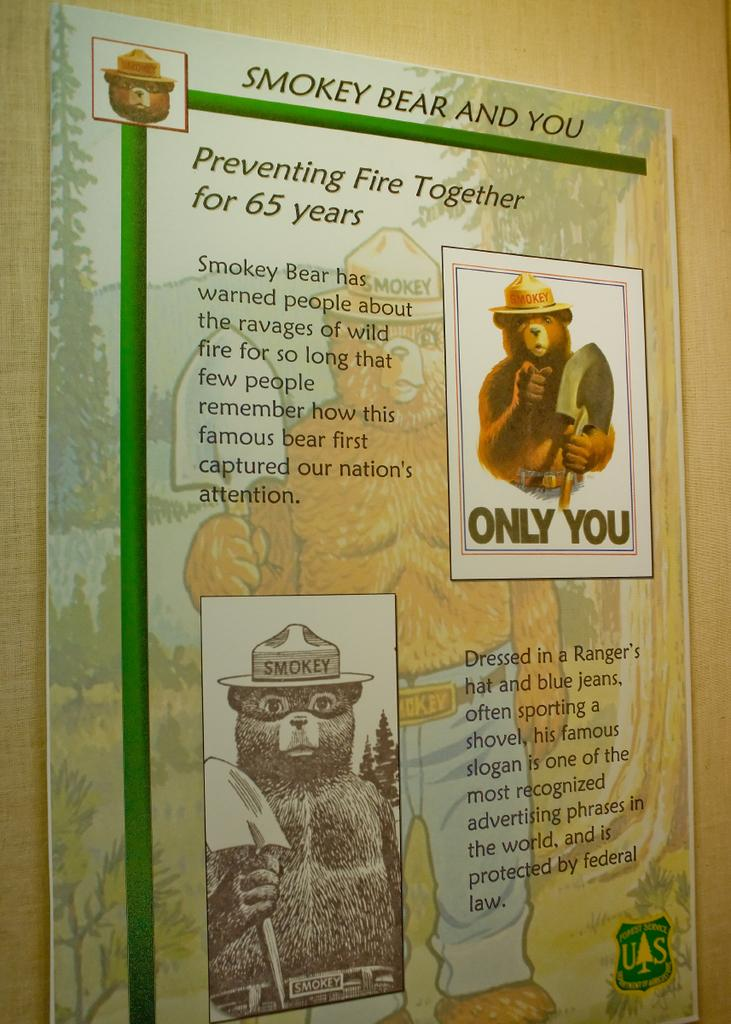<image>
Provide a brief description of the given image. A Smokey the Bear display contains his famous slogan. 